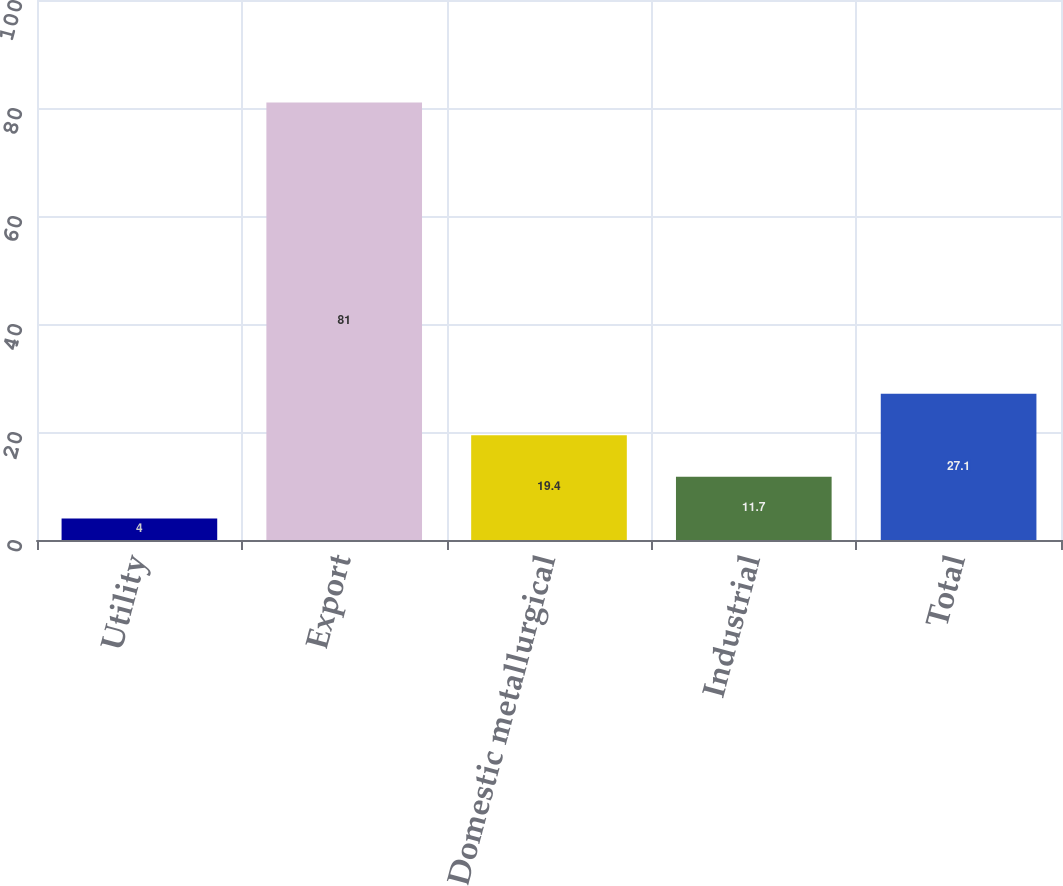Convert chart to OTSL. <chart><loc_0><loc_0><loc_500><loc_500><bar_chart><fcel>Utility<fcel>Export<fcel>Domestic metallurgical<fcel>Industrial<fcel>Total<nl><fcel>4<fcel>81<fcel>19.4<fcel>11.7<fcel>27.1<nl></chart> 